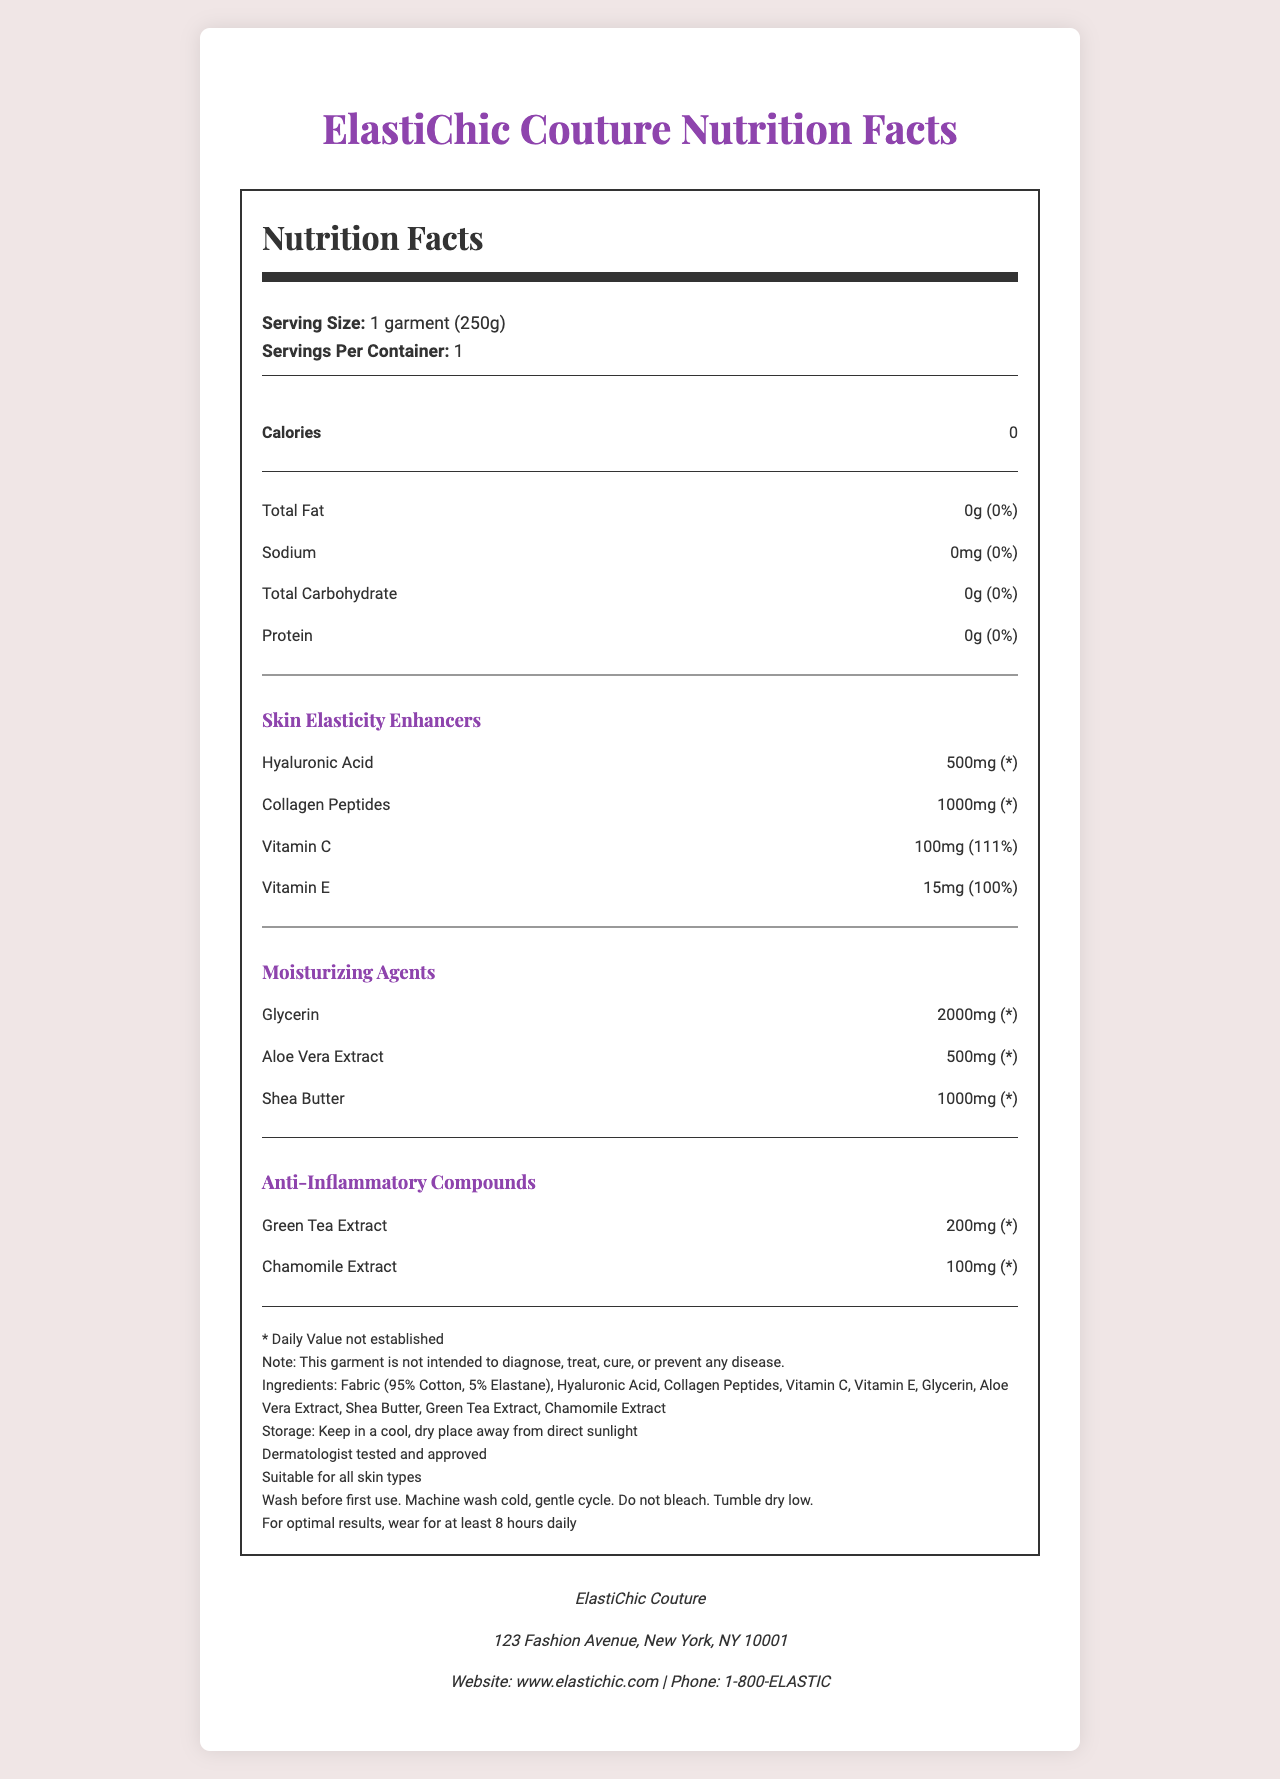what is the serving size of the garment? The document mentions "Serving Size: 1 garment (250g)" under the Nutrition Facts section.
Answer: 1 garment (250g) how much Vitamin C is included in the garment? Under the "Skin Elasticity Enhancers" section, the document states that there are 100mg of Vitamin C.
Answer: 100mg what is the address of the manufacturer? The manufacturer’s address is listed under the “Manufacturer Info” section: "123 Fashion Avenue, New York, NY 10001."
Answer: 123 Fashion Avenue, New York, NY 10001 which of the following is NOT a skin elasticity enhancer included in the garment? A. Collagen Peptides B. Hyaluronic Acid C. Glycerin Glycerin is listed under "Moisturizing Agents," while Collagen Peptides and Hyaluronic Acid are listed under "Skin Elasticity Enhancers."
Answer: C. Glycerin how should the garment be washed? The document states in the additional info section: "Wash before first use. Machine wash cold, gentle cycle. Do not bleach. Tumble dry low."
Answer: Machine wash cold, gentle cycle. Do not bleach. Tumble dry low. does the garment contain any fat? The document under the Nutrition Facts section shows "Total Fat: 0g (0%)."
Answer: No what percentage of the daily value of Vitamin E does one garment provide? A. 50% B. 75% C. 100% D. 125% The document mentions that the garment provides "15mg (100%)" of Vitamin E under the "Skin Elasticity Enhancers" section.
Answer: C. 100% are there calories in the garment? The document states under the Nutrition Facts section that "Calories: 0."
Answer: No can the garment diagnose or treat any medical condition? According to the additional information, "This garment is not intended to diagnose, treat, cure, or prevent any disease."
Answer: No what are the main moisturizing agents in the garment? Under the "Moisturizing Agents" section, the garment includes Glycerin, Aloe Vera Extract, and Shea Butter.
Answer: Glycerin, Aloe Vera Extract, Shea Butter summarize the document's purpose and main information. The document includes a "Nutrition Facts" section that shows no macronutrients or calories, lists various skin elasticity enhancers like Hyaluronic Acid and Collagen Peptides, moisturizers such as Glycerin and Shea Butter, and anti-inflammatory compounds like Green Tea Extract. It also contains additional care instructions and manufacturer contact information.
Answer: The document provides detailed nutritional information, skin-enhancing properties, moisturizing agents, and manufacturer details of a garment designed to improve skin elasticity. how much chamomile extract does the garment contain? The "Anti-Inflammatory Compounds" section lists "Chamomile Extract: 100mg."
Answer: 100mg is the daily value for total carbohydrate listed? The document lists "Total Carbohydrate: 0g (0%)" in the Nutrition Facts section.
Answer: Yes how many servings are there per container? According to the Nutrition Facts, there is "1 serving per container."
Answer: 1 which of the following vitamins is included for enhancing skin elasticity? A. Vitamin A B. Vitamin B12 C. Vitamin C The document lists Vitamin C under "Skin Elasticity Enhancers."
Answer: C. Vitamin C how much sodium is present in the garment? The Nutrition Facts section lists "Sodium: 0mg (0%)."
Answer: 0mg what is the main purpose of the garment as advertised? The garment includes skin elasticity enhancers, moisturizers, and anti-inflammatory compounds, indicating its main purpose is to improve skin elasticity and provide moisturization for the wearer.
Answer: Enhancing skin elasticity and providing moisturization is the daily value for Collagen Peptides established? The document notes "* Daily Value not established" for Collagen Peptides under "Skin Elasticity Enhancers."
Answer: No what is the main color theme of the document design? From the description of the document's HTML and CSS, the primary colors are white (background) and purple (text and headings).
Answer: White and Purple where should the garment be stored? The additional info section states: "Storage: Keep in a cool, dry place away from direct sunlight."
Answer: In a cool, dry place away from direct sunlight does the document provide any usage duration recommendations for optimal results? The document suggests: "For optimal results, wear for at least 8 hours daily."
Answer: Yes what is the phone number of the manufacturer? The "Manufacturer Info" section lists the phone number as "1-800-ELASTIC."
Answer: 1-800-ELASTIC how many grams does one garment weigh? The serving size information indicates "1 garment (250g)."
Answer: 250g 